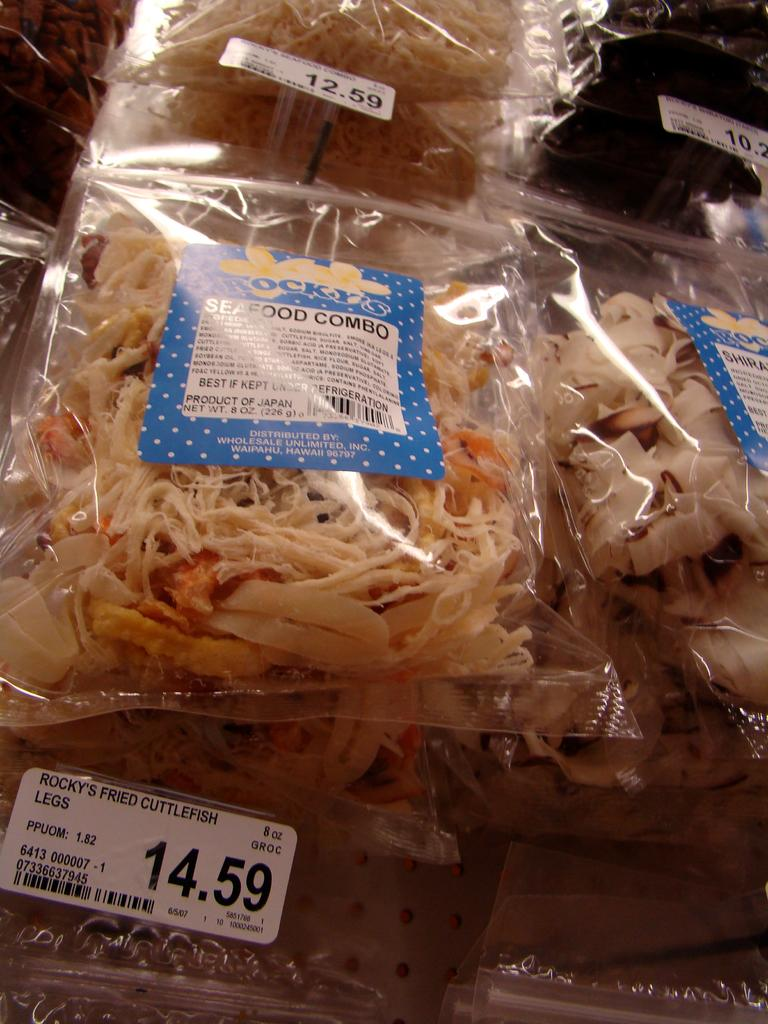What type of objects can be seen in the image? There are food items in the image. How are the food items packaged? The food items are packed in covers. Are there any additional elements on the food item covers? Yes, there are stickers on the food item covers. What type of fruit can be seen emitting smoke in the image? There is no fruit or smoke present in the image. How many spiders are crawling on the food items in the image? There are no spiders present in the image. 